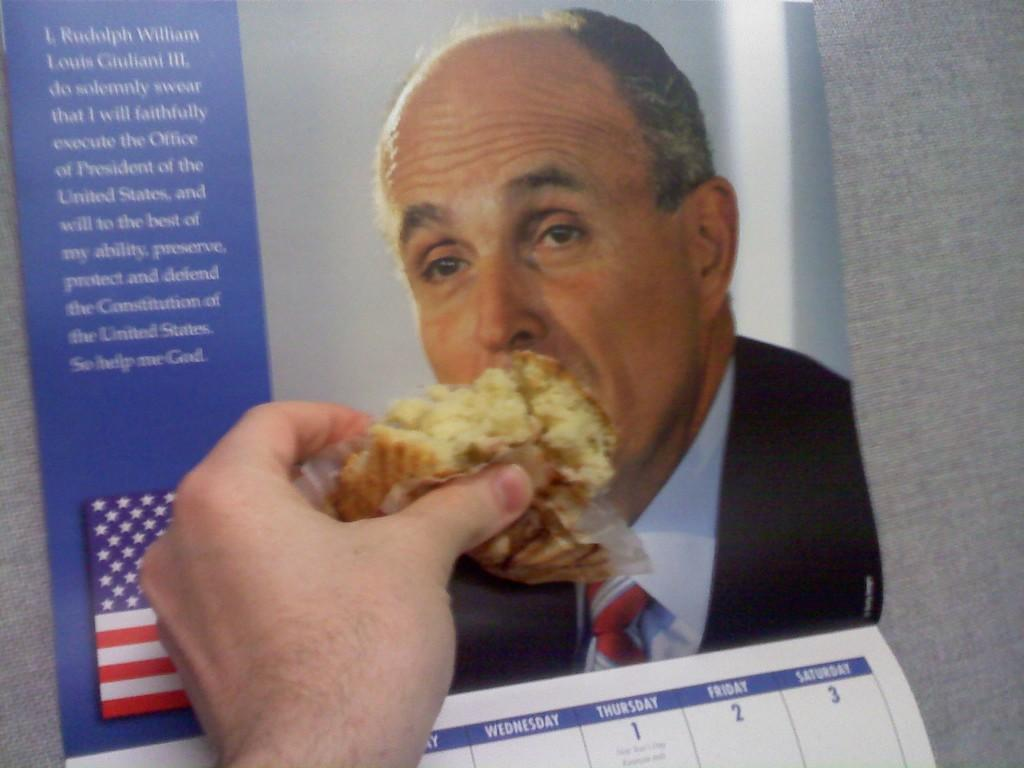<image>
Give a short and clear explanation of the subsequent image. A hand feeds a picture of Rudolph William Louis Giuliani in a calendar. 